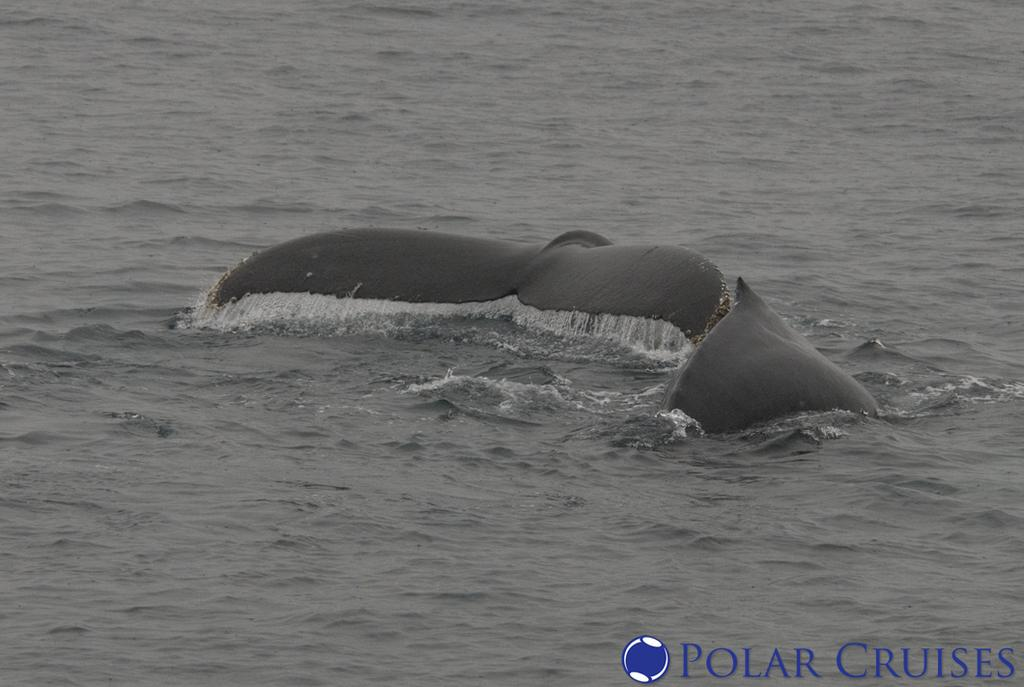What type of animals can be seen in the image? There are two sea animals in the image. Where are the sea animals located? The sea animals are in the water. What type of peace symbol can be seen hanging from the locket in the image? There is no peace symbol or locket present in the image; it features two sea animals in the water. What type of club is visible in the image? There is no club present in the image; it features two sea animals in the water. 